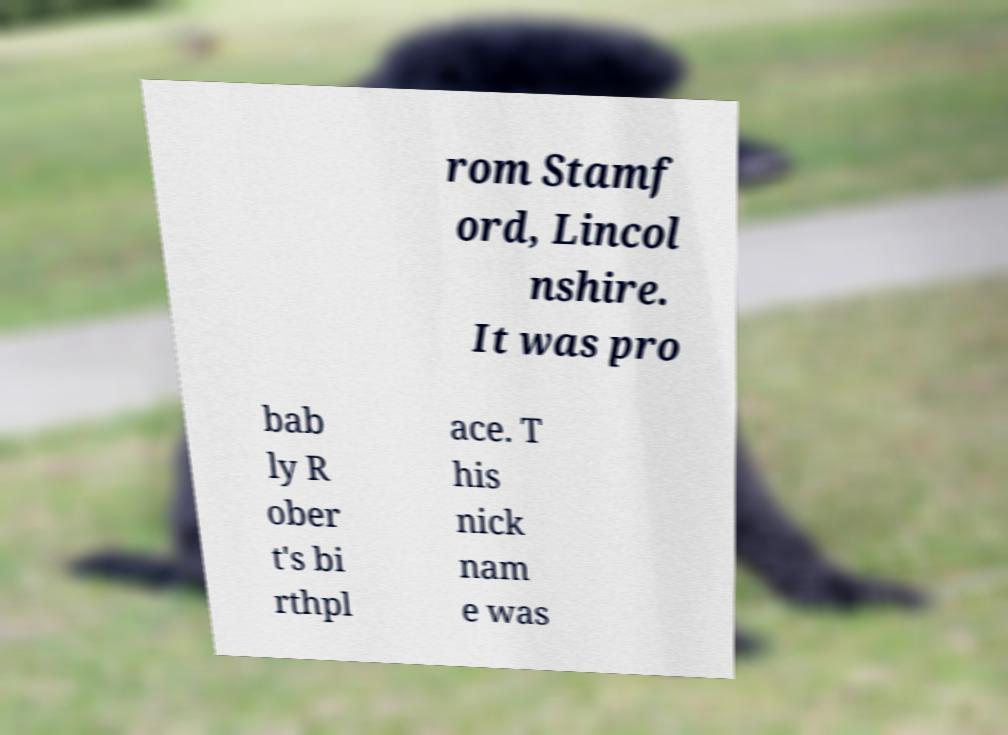Could you extract and type out the text from this image? rom Stamf ord, Lincol nshire. It was pro bab ly R ober t's bi rthpl ace. T his nick nam e was 